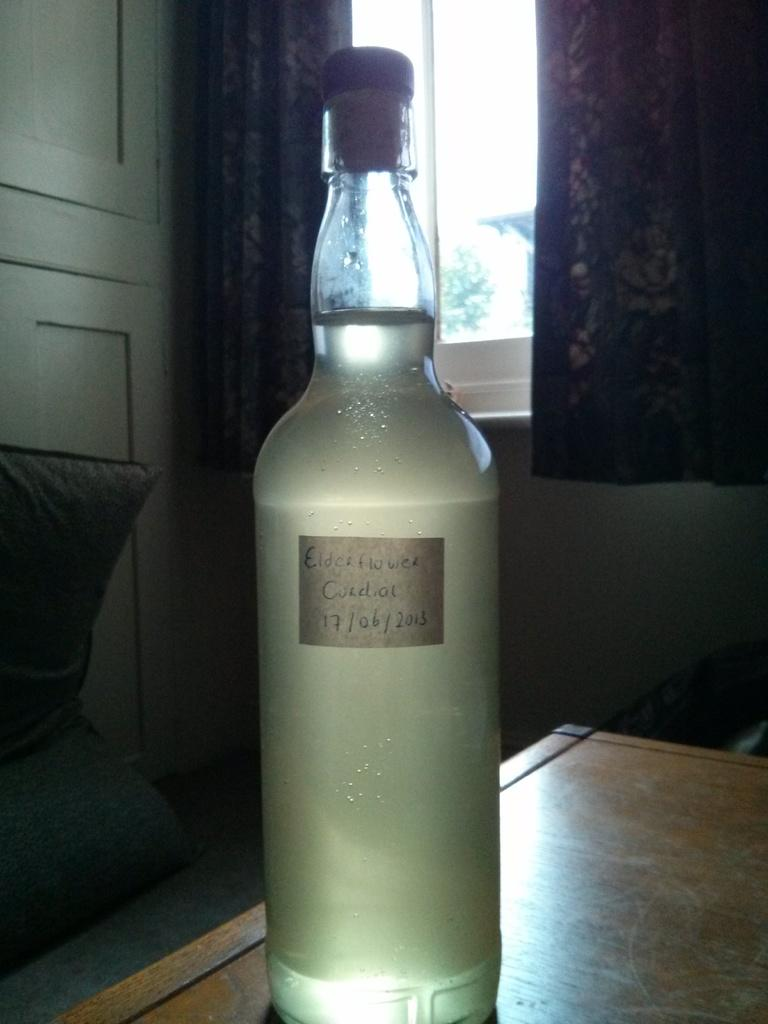What object is on the table in the image? There is a bottle on the table in the image. What can be seen in the background of the image? There is a window in the image. Is there any window treatment present in the image? Yes, there is a curtain associated with the window. How many clocks are visible on the wall in the image? There are no clocks visible on the wall in the image. 